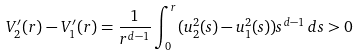Convert formula to latex. <formula><loc_0><loc_0><loc_500><loc_500>V _ { 2 } ^ { \prime } ( r ) - V _ { 1 } ^ { \prime } ( r ) = \frac { 1 } { r ^ { d - 1 } } \int _ { 0 } ^ { r } ( u _ { 2 } ^ { 2 } ( s ) - u _ { 1 } ^ { 2 } ( s ) ) s ^ { d - 1 } \, d s > 0</formula> 